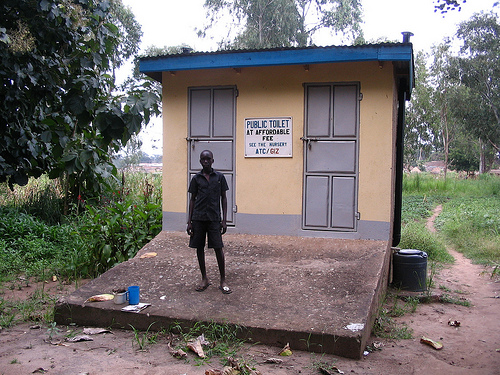<image>
Is there a wood chunk under the vent? Yes. The wood chunk is positioned underneath the vent, with the vent above it in the vertical space. 